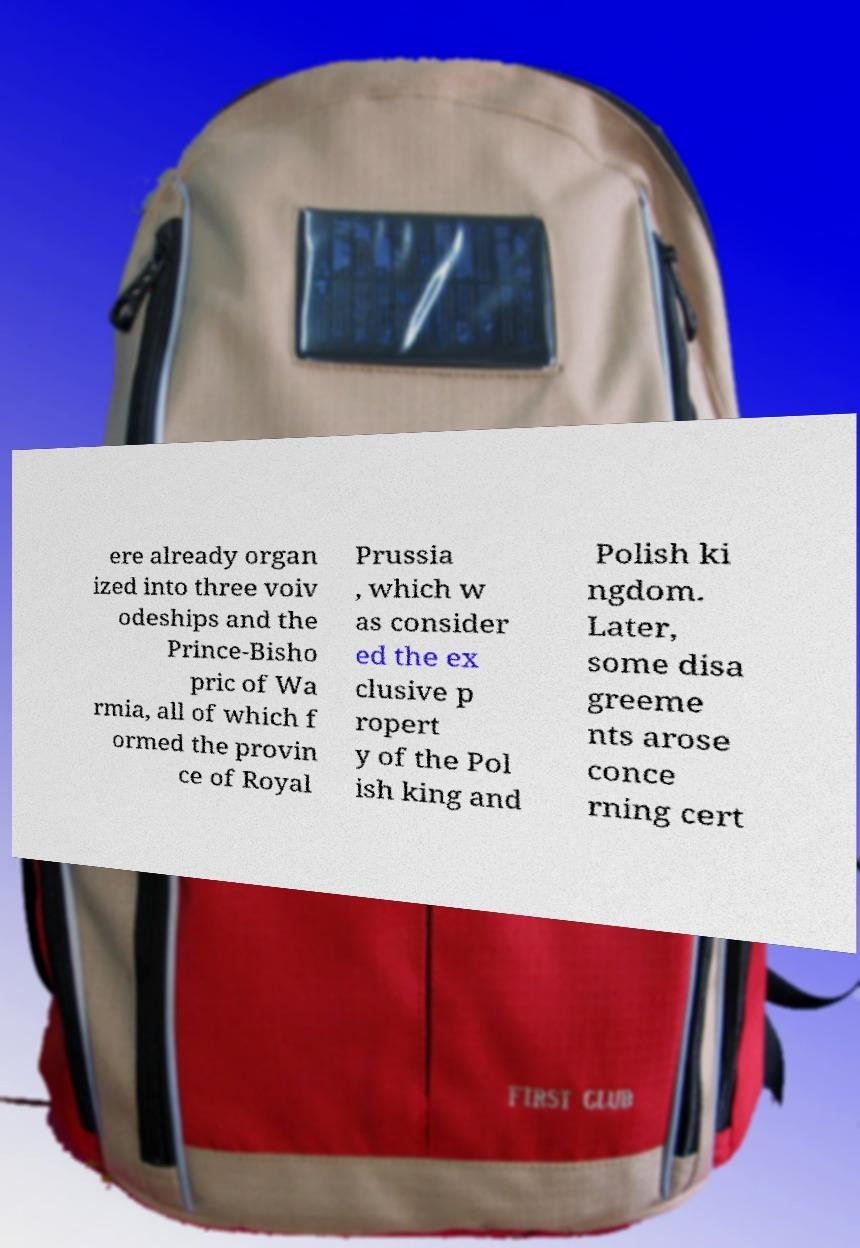I need the written content from this picture converted into text. Can you do that? ere already organ ized into three voiv odeships and the Prince-Bisho pric of Wa rmia, all of which f ormed the provin ce of Royal Prussia , which w as consider ed the ex clusive p ropert y of the Pol ish king and Polish ki ngdom. Later, some disa greeme nts arose conce rning cert 